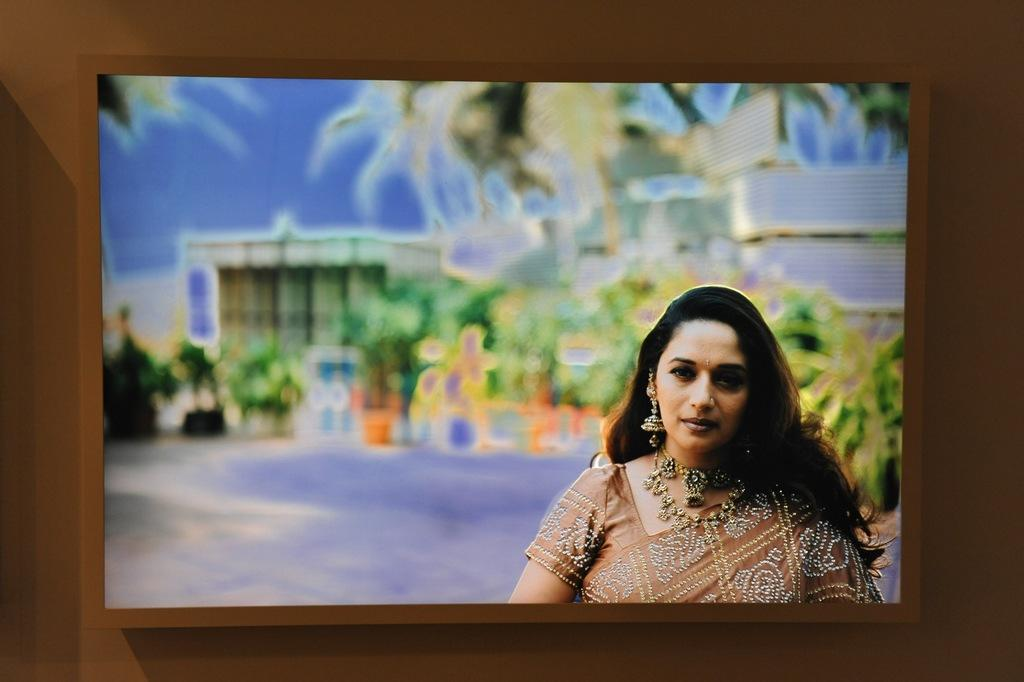What is the person in the image wearing? The person in the image is wearing a brown dress. What can be seen in the background of the image? There are many trees and a house visible in the background. How is the sky depicted in the image? The sky is visible in the background, but it is blurry. What type of screw is being used to transport the property in the image? There is no screw or property visible in the image, so it is not possible to answer that question. 